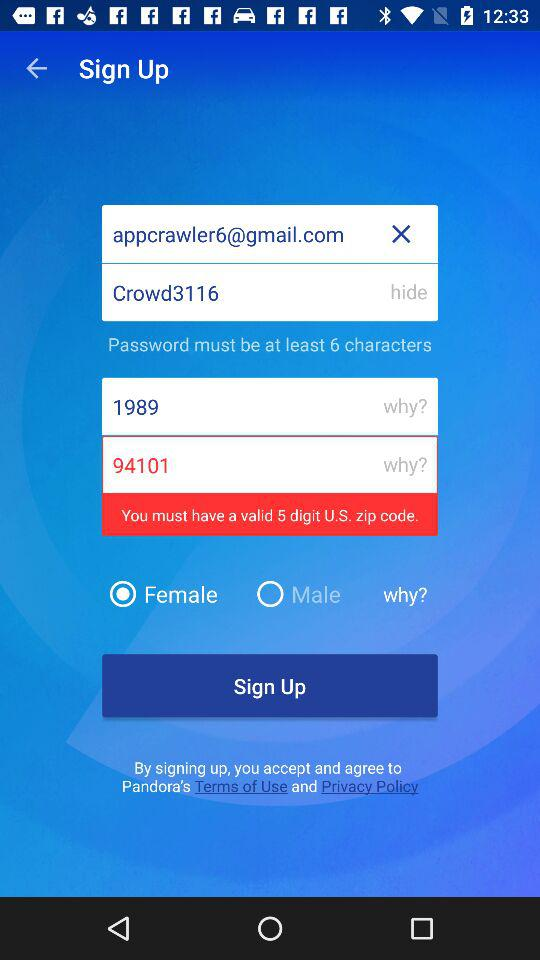What is the password? The password is "Crowd3116". 